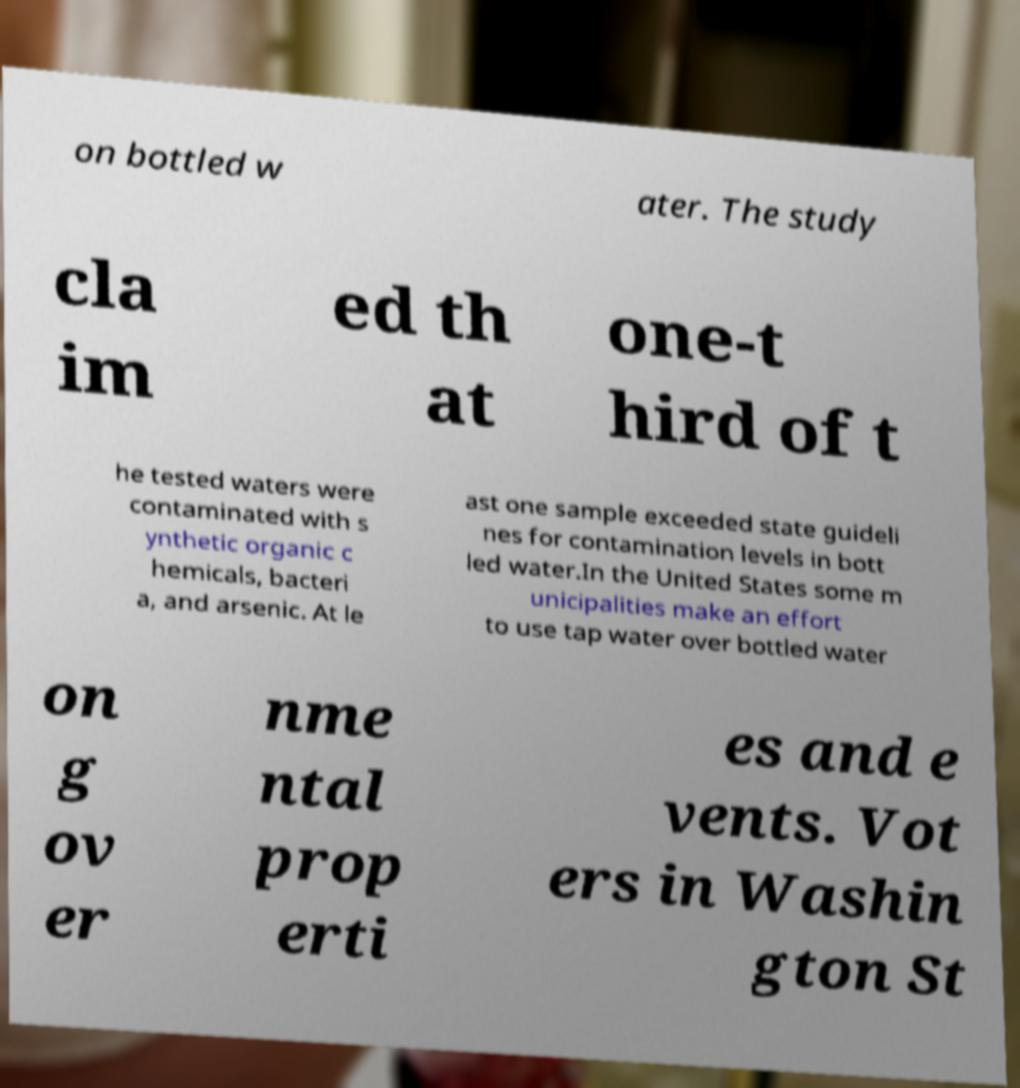Can you read and provide the text displayed in the image?This photo seems to have some interesting text. Can you extract and type it out for me? on bottled w ater. The study cla im ed th at one-t hird of t he tested waters were contaminated with s ynthetic organic c hemicals, bacteri a, and arsenic. At le ast one sample exceeded state guideli nes for contamination levels in bott led water.In the United States some m unicipalities make an effort to use tap water over bottled water on g ov er nme ntal prop erti es and e vents. Vot ers in Washin gton St 